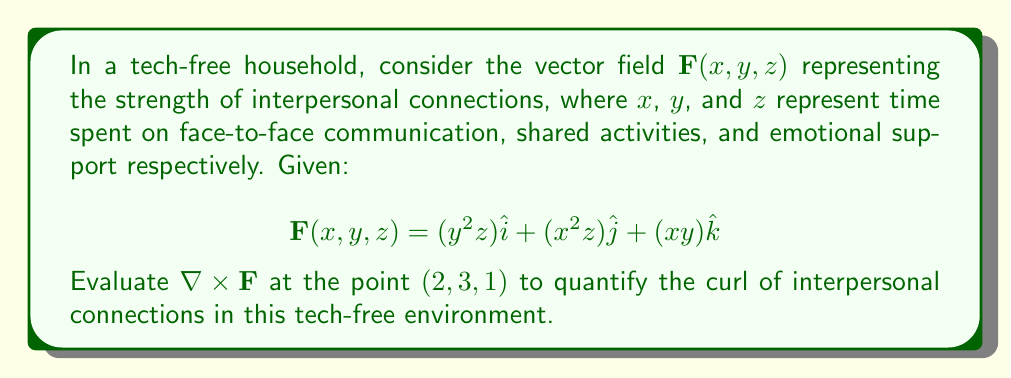Can you answer this question? To evaluate the curl of $\mathbf{F}$ at $(2,3,1)$, we need to follow these steps:

1) Recall the formula for curl in 3D:

   $$\nabla \times \mathbf{F} = \left(\frac{\partial F_z}{\partial y} - \frac{\partial F_y}{\partial z}\right)\hat{i} + \left(\frac{\partial F_x}{\partial z} - \frac{\partial F_z}{\partial x}\right)\hat{j} + \left(\frac{\partial F_y}{\partial x} - \frac{\partial F_x}{\partial y}\right)\hat{k}$$

2) Calculate the partial derivatives:
   
   $\frac{\partial F_z}{\partial y} = x$
   $\frac{\partial F_y}{\partial z} = x^2$
   $\frac{\partial F_x}{\partial z} = y^2$
   $\frac{\partial F_z}{\partial x} = y$
   $\frac{\partial F_y}{\partial x} = 2xz$
   $\frac{\partial F_x}{\partial y} = 2yz$

3) Substitute these into the curl formula:

   $$\nabla \times \mathbf{F} = (x - x^2)\hat{i} + (y^2 - y)\hat{j} + (2xz - 2yz)\hat{k}$$

4) Evaluate at the point $(2,3,1)$:

   $$\nabla \times \mathbf{F}|_{(2,3,1)} = (2 - 4)\hat{i} + (9 - 3)\hat{j} + (4 - 6)\hat{k}$$

5) Simplify:

   $$\nabla \times \mathbf{F}|_{(2,3,1)} = -2\hat{i} + 6\hat{j} - 2\hat{k}$$

This result quantifies the rotation of interpersonal connections in the tech-free household at the given point.
Answer: $-2\hat{i} + 6\hat{j} - 2\hat{k}$ 